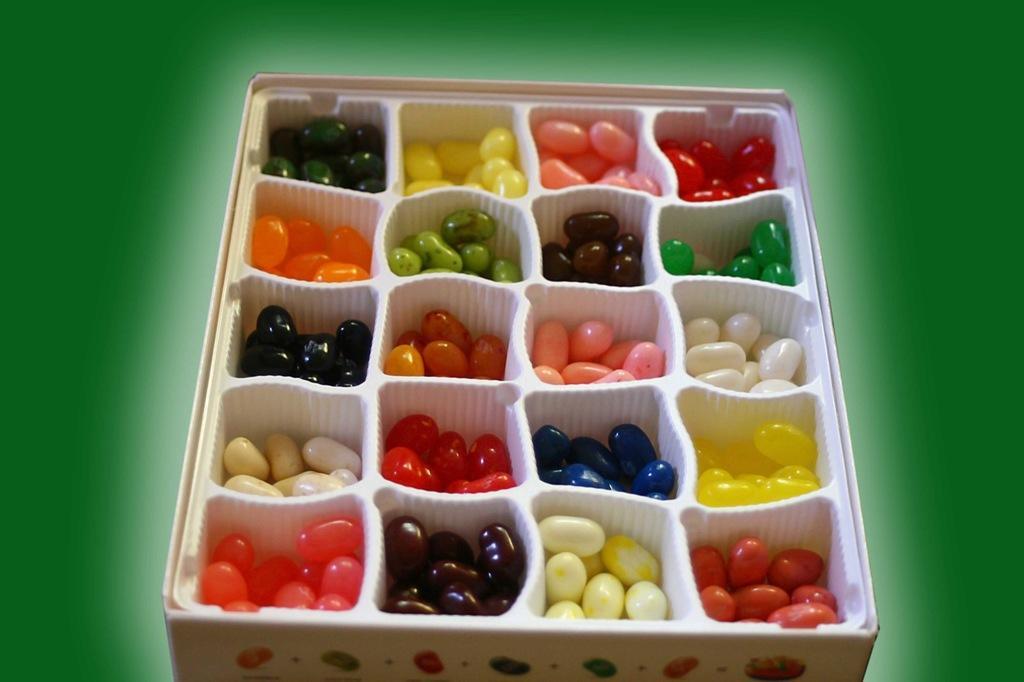Please provide a concise description of this image. In this picture, it seems like colorful gems. 